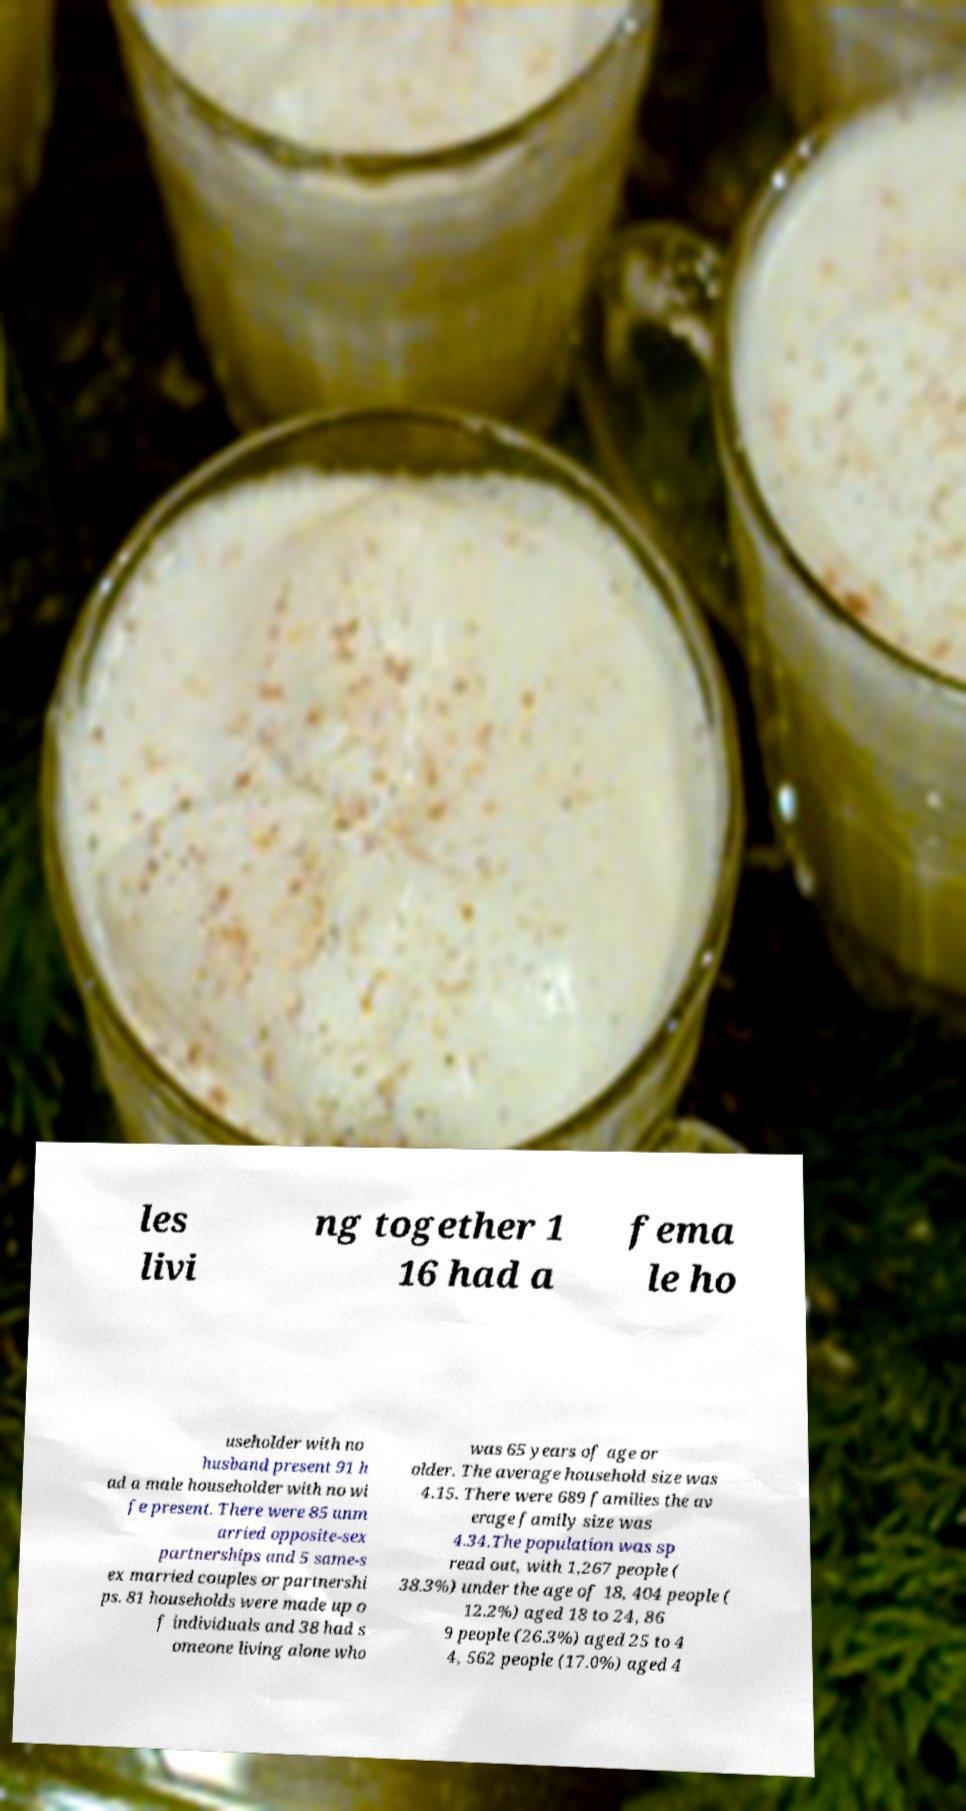For documentation purposes, I need the text within this image transcribed. Could you provide that? les livi ng together 1 16 had a fema le ho useholder with no husband present 91 h ad a male householder with no wi fe present. There were 85 unm arried opposite-sex partnerships and 5 same-s ex married couples or partnershi ps. 81 households were made up o f individuals and 38 had s omeone living alone who was 65 years of age or older. The average household size was 4.15. There were 689 families the av erage family size was 4.34.The population was sp read out, with 1,267 people ( 38.3%) under the age of 18, 404 people ( 12.2%) aged 18 to 24, 86 9 people (26.3%) aged 25 to 4 4, 562 people (17.0%) aged 4 